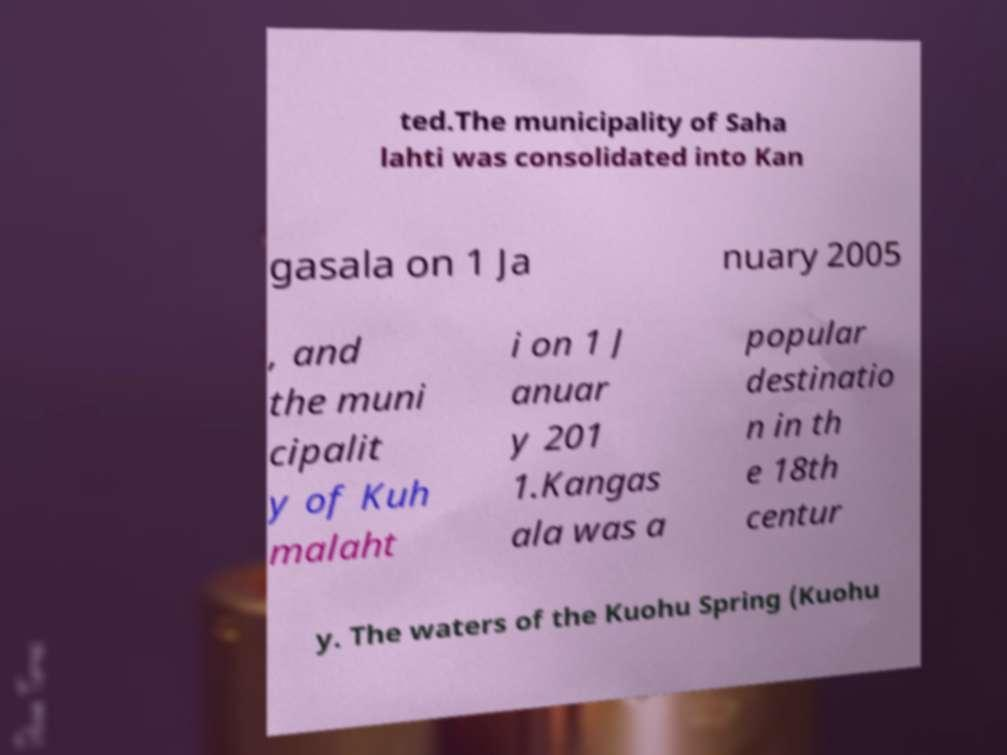What messages or text are displayed in this image? I need them in a readable, typed format. ted.The municipality of Saha lahti was consolidated into Kan gasala on 1 Ja nuary 2005 , and the muni cipalit y of Kuh malaht i on 1 J anuar y 201 1.Kangas ala was a popular destinatio n in th e 18th centur y. The waters of the Kuohu Spring (Kuohu 